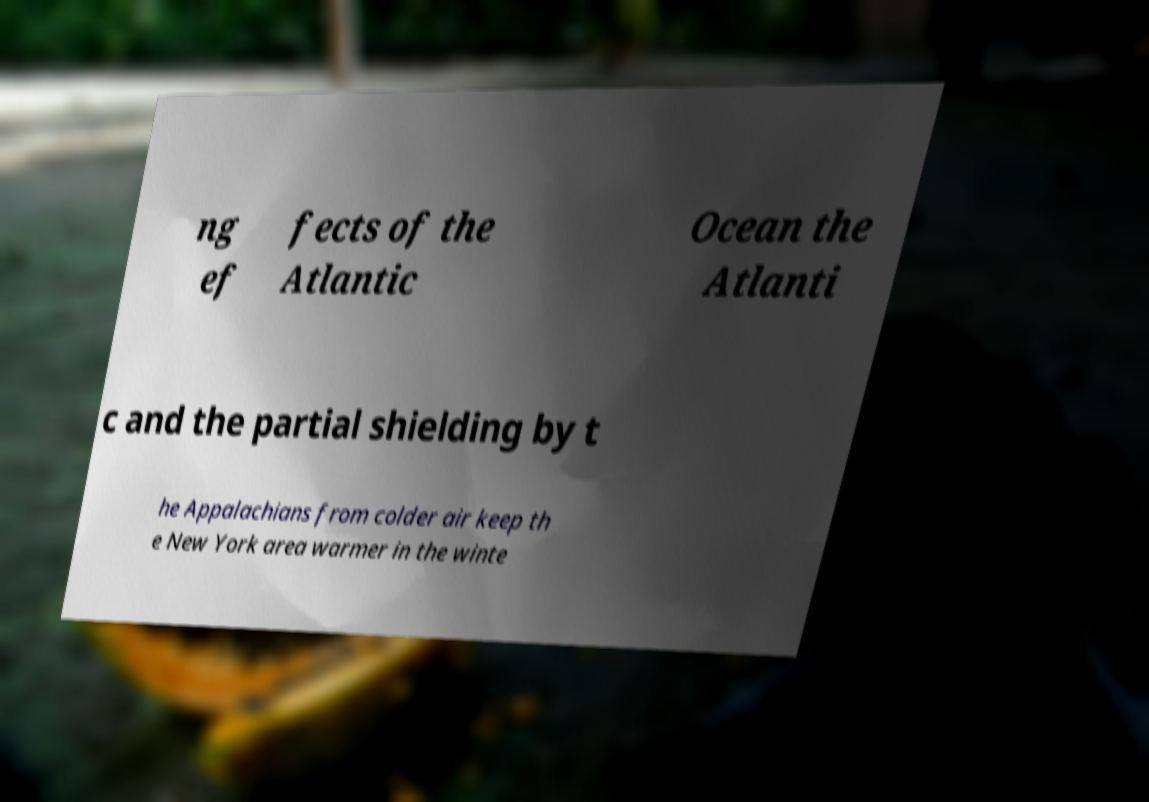Could you assist in decoding the text presented in this image and type it out clearly? ng ef fects of the Atlantic Ocean the Atlanti c and the partial shielding by t he Appalachians from colder air keep th e New York area warmer in the winte 